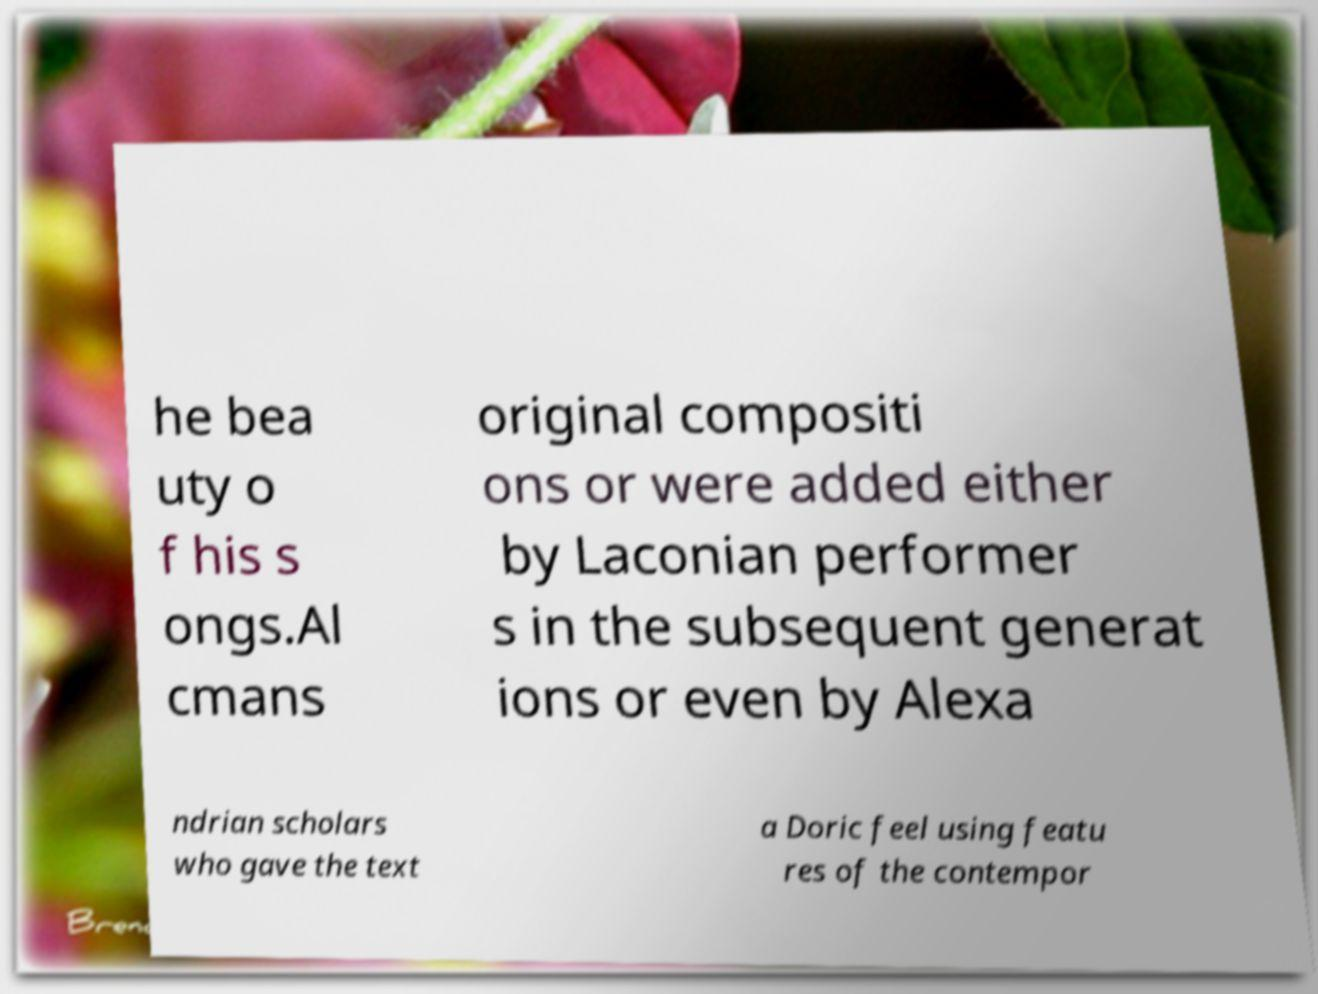Could you extract and type out the text from this image? he bea uty o f his s ongs.Al cmans original compositi ons or were added either by Laconian performer s in the subsequent generat ions or even by Alexa ndrian scholars who gave the text a Doric feel using featu res of the contempor 